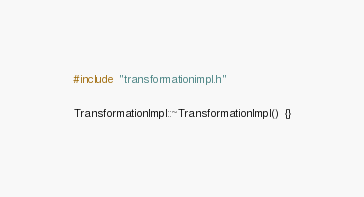Convert code to text. <code><loc_0><loc_0><loc_500><loc_500><_C++_>#include "transformationimpl.h"

TransformationImpl::~TransformationImpl() {}
</code> 